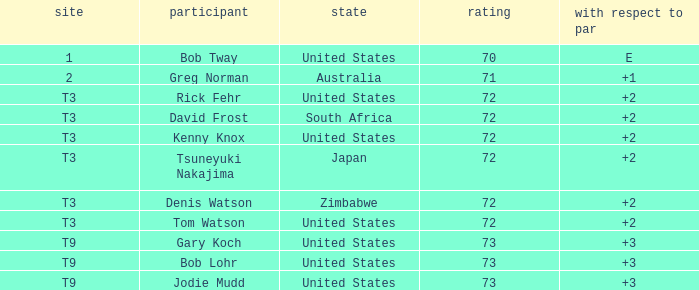What is the low score for TO par +2 in japan? 72.0. Would you be able to parse every entry in this table? {'header': ['site', 'participant', 'state', 'rating', 'with respect to par'], 'rows': [['1', 'Bob Tway', 'United States', '70', 'E'], ['2', 'Greg Norman', 'Australia', '71', '+1'], ['T3', 'Rick Fehr', 'United States', '72', '+2'], ['T3', 'David Frost', 'South Africa', '72', '+2'], ['T3', 'Kenny Knox', 'United States', '72', '+2'], ['T3', 'Tsuneyuki Nakajima', 'Japan', '72', '+2'], ['T3', 'Denis Watson', 'Zimbabwe', '72', '+2'], ['T3', 'Tom Watson', 'United States', '72', '+2'], ['T9', 'Gary Koch', 'United States', '73', '+3'], ['T9', 'Bob Lohr', 'United States', '73', '+3'], ['T9', 'Jodie Mudd', 'United States', '73', '+3']]} 